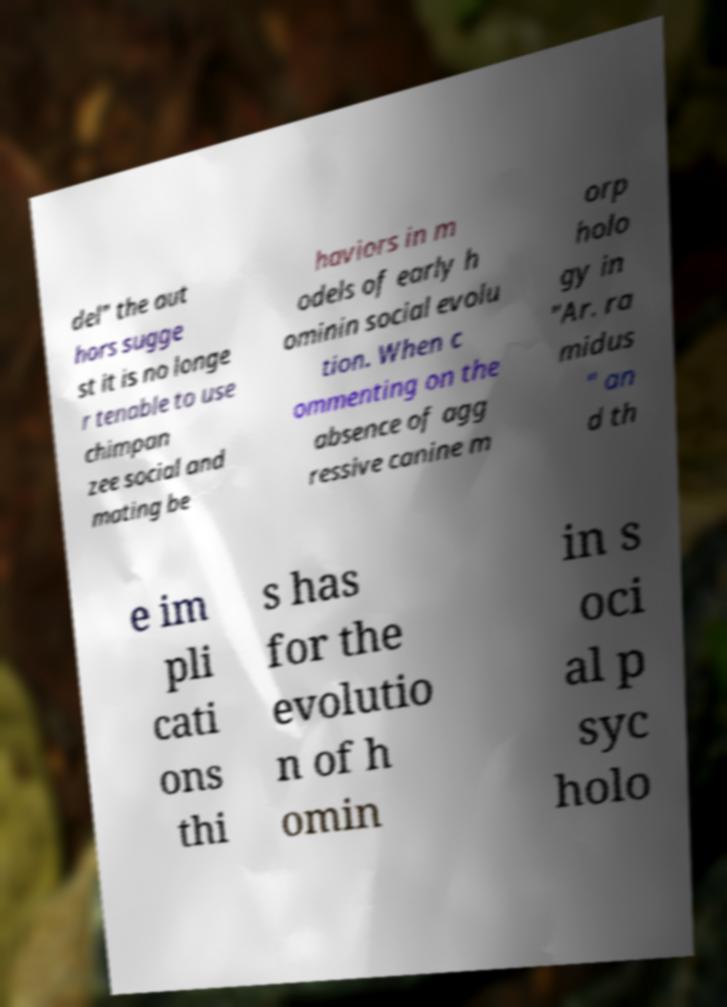Can you accurately transcribe the text from the provided image for me? del" the aut hors sugge st it is no longe r tenable to use chimpan zee social and mating be haviors in m odels of early h ominin social evolu tion. When c ommenting on the absence of agg ressive canine m orp holo gy in "Ar. ra midus " an d th e im pli cati ons thi s has for the evolutio n of h omin in s oci al p syc holo 